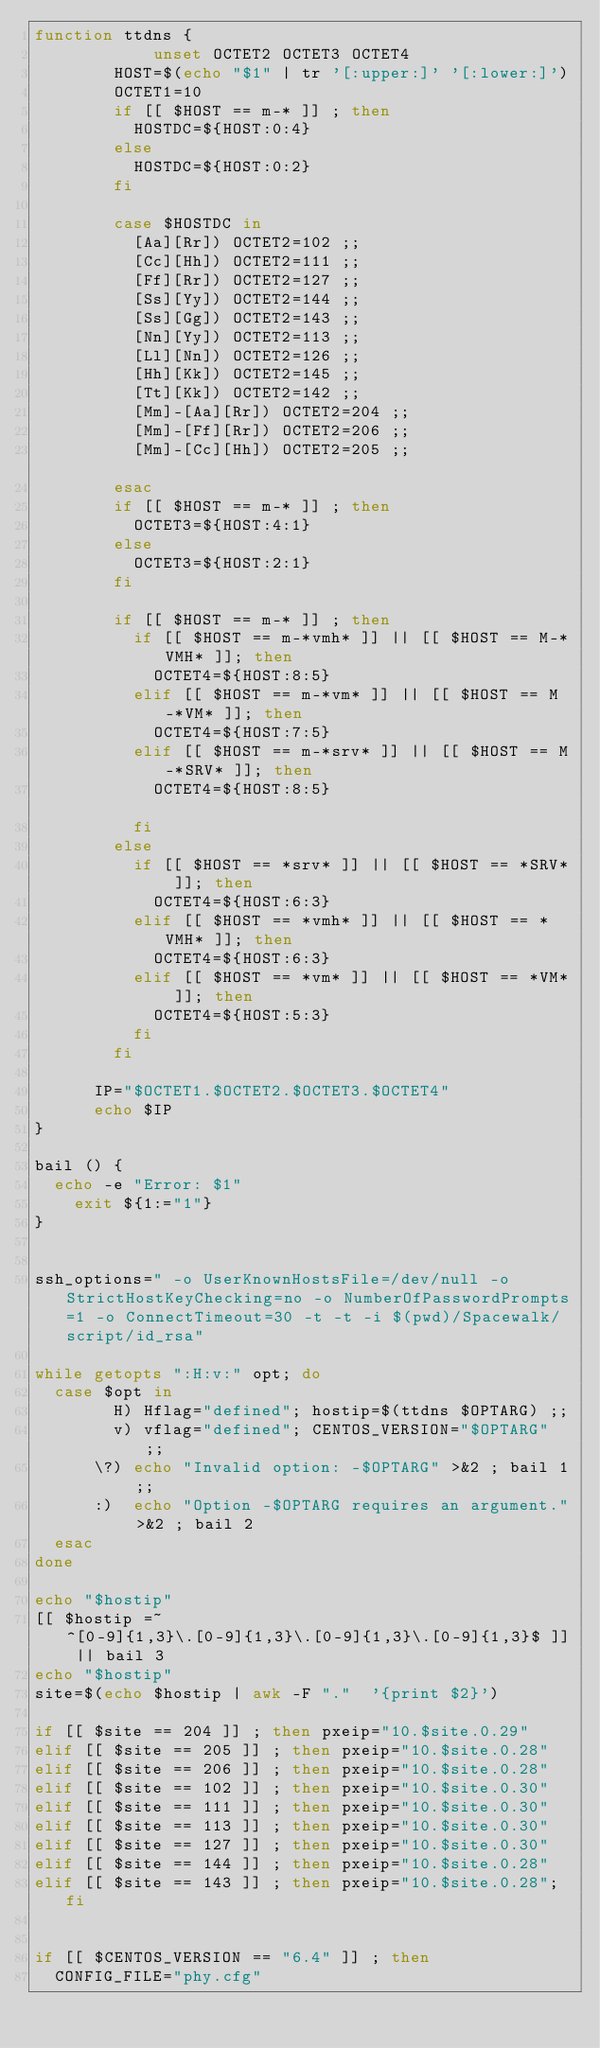Convert code to text. <code><loc_0><loc_0><loc_500><loc_500><_Bash_>function ttdns {
       			unset OCTET2 OCTET3 OCTET4	
				HOST=$(echo "$1" | tr '[:upper:]' '[:lower:]')
				OCTET1=10
				if [[ $HOST == m-* ]] ; then
					HOSTDC=${HOST:0:4}
				else
					HOSTDC=${HOST:0:2}
				fi

				case $HOSTDC in
					[Aa][Rr]) OCTET2=102 ;;
					[Cc][Hh]) OCTET2=111 ;;
					[Ff][Rr]) OCTET2=127 ;;
					[Ss][Yy]) OCTET2=144 ;;
					[Ss][Gg]) OCTET2=143 ;;
					[Nn][Yy]) OCTET2=113 ;;
					[Ll][Nn]) OCTET2=126 ;;
					[Hh][Kk]) OCTET2=145 ;;
					[Tt][Kk]) OCTET2=142 ;;
					[Mm]-[Aa][Rr]) OCTET2=204 ;;
					[Mm]-[Ff][Rr]) OCTET2=206 ;;	
					[Mm]-[Cc][Hh]) OCTET2=205 ;;																	
				esac
				if [[ $HOST == m-* ]] ; then
					OCTET3=${HOST:4:1}
				else
					OCTET3=${HOST:2:1}
				fi
				
				if [[ $HOST == m-* ]] ; then
					if [[ $HOST == m-*vmh* ]] || [[ $HOST == M-*VMH* ]]; then
						OCTET4=${HOST:8:5}	
					elif [[ $HOST == m-*vm* ]] || [[ $HOST == M-*VM* ]]; then
						OCTET4=${HOST:7:5}
					elif [[ $HOST == m-*srv* ]] || [[ $HOST == M-*SRV* ]]; then
						OCTET4=${HOST:8:5}																	
					fi
				else	
					if [[ $HOST == *srv* ]] || [[ $HOST == *SRV* ]]; then
						OCTET4=${HOST:6:3}
					elif [[ $HOST == *vmh* ]] || [[ $HOST == *VMH* ]]; then
						OCTET4=${HOST:6:3}
					elif [[ $HOST == *vm* ]] || [[ $HOST == *VM* ]]; then
						OCTET4=${HOST:5:3}
					fi
				fi	

			IP="$OCTET1.$OCTET2.$OCTET3.$OCTET4"
			echo $IP
} 

bail () {
	echo -e "Error: $1"
  	exit ${1:="1"}
}


ssh_options=" -o UserKnownHostsFile=/dev/null -o StrictHostKeyChecking=no -o NumberOfPasswordPrompts=1 -o ConnectTimeout=30 -t -t -i $(pwd)/Spacewalk/script/id_rsa"

while getopts ":H:v:" opt; do
  case $opt in
        H) Hflag="defined"; hostip=$(ttdns $OPTARG) ;;
        v) vflag="defined"; CENTOS_VERSION="$OPTARG" ;;
    	\?) echo "Invalid option: -$OPTARG" >&2 ; bail 1 ;;
    	:)  echo "Option -$OPTARG requires an argument." >&2 ; bail 2      
  esac
done

echo "$hostip"
[[ $hostip =~ ^[0-9]{1,3}\.[0-9]{1,3}\.[0-9]{1,3}\.[0-9]{1,3}$ ]] || bail 3
echo "$hostip"
site=$(echo $hostip | awk -F "."  '{print $2}')

if [[ $site == 204 ]] ; then pxeip="10.$site.0.29"
elif [[ $site == 205 ]] ; then pxeip="10.$site.0.28"
elif [[ $site == 206 ]] ; then pxeip="10.$site.0.28"
elif [[ $site == 102 ]] ; then pxeip="10.$site.0.30"
elif [[ $site == 111 ]] ; then pxeip="10.$site.0.30"
elif [[ $site == 113 ]] ; then pxeip="10.$site.0.30"
elif [[ $site == 127 ]] ; then pxeip="10.$site.0.30"
elif [[ $site == 144 ]] ; then pxeip="10.$site.0.28"
elif [[ $site == 143 ]] ; then pxeip="10.$site.0.28"; fi


if [[ $CENTOS_VERSION == "6.4" ]] ; then 
	CONFIG_FILE="phy.cfg"</code> 